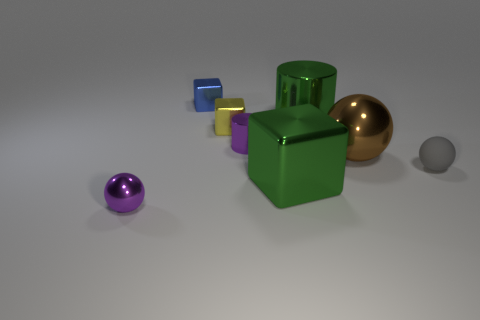Subtract all red cylinders. Subtract all purple blocks. How many cylinders are left? 2 Subtract all yellow balls. How many red cubes are left? 0 Add 5 large grays. How many greens exist? 0 Subtract all large yellow cubes. Subtract all large brown objects. How many objects are left? 7 Add 6 metal cubes. How many metal cubes are left? 9 Add 3 small blue matte objects. How many small blue matte objects exist? 3 Add 1 yellow cubes. How many objects exist? 9 Subtract all gray balls. How many balls are left? 2 Subtract all tiny gray rubber spheres. How many spheres are left? 2 Subtract 0 gray cylinders. How many objects are left? 8 